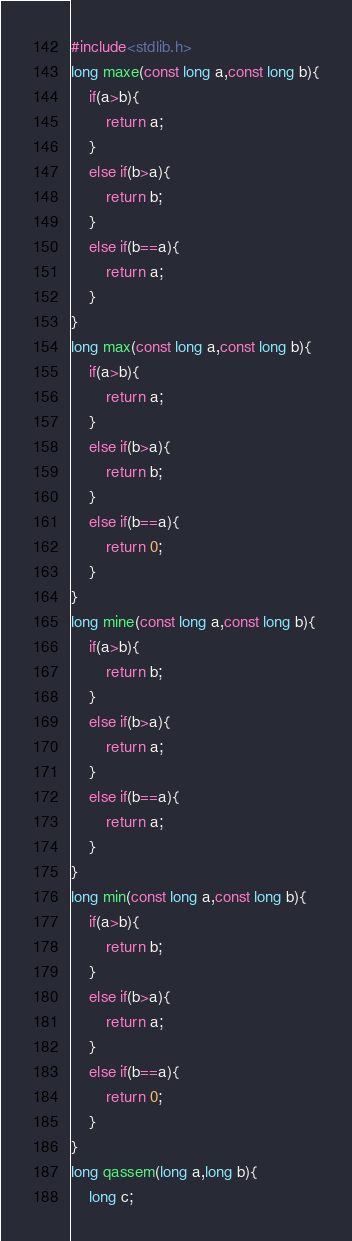<code> <loc_0><loc_0><loc_500><loc_500><_C_>#include<stdlib.h>
long maxe(const long a,const long b){
	if(a>b){
		return a;
	} 
	else if(b>a){
		return b;
	}
	else if(b==a){
		return a;
	}
}
long max(const long a,const long b){
	if(a>b){
		return a;
	} 
	else if(b>a){
		return b;
	}
	else if(b==a){
		return 0;
	}
}
long mine(const long a,const long b){
	if(a>b){
		return b;
	} 
	else if(b>a){
		return a;
	}
	else if(b==a){
		return a;
	}
}
long min(const long a,const long b){
	if(a>b){
		return b;
	} 
	else if(b>a){
		return a;
	}
	else if(b==a){
		return 0;
	}
}
long qassem(long a,long b){
	long c;</code> 